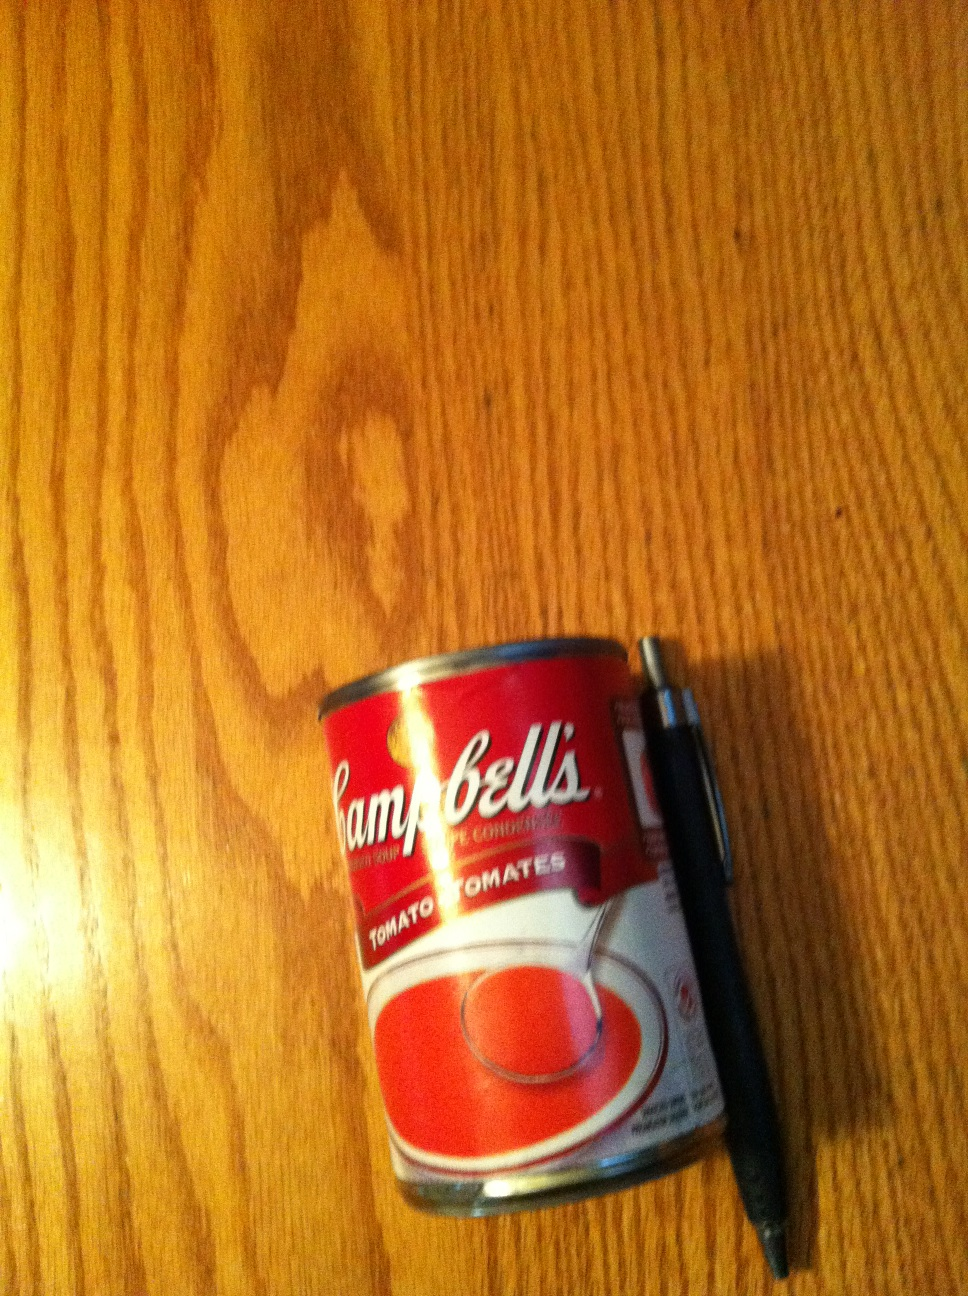What is this? from Vizwiz soup 